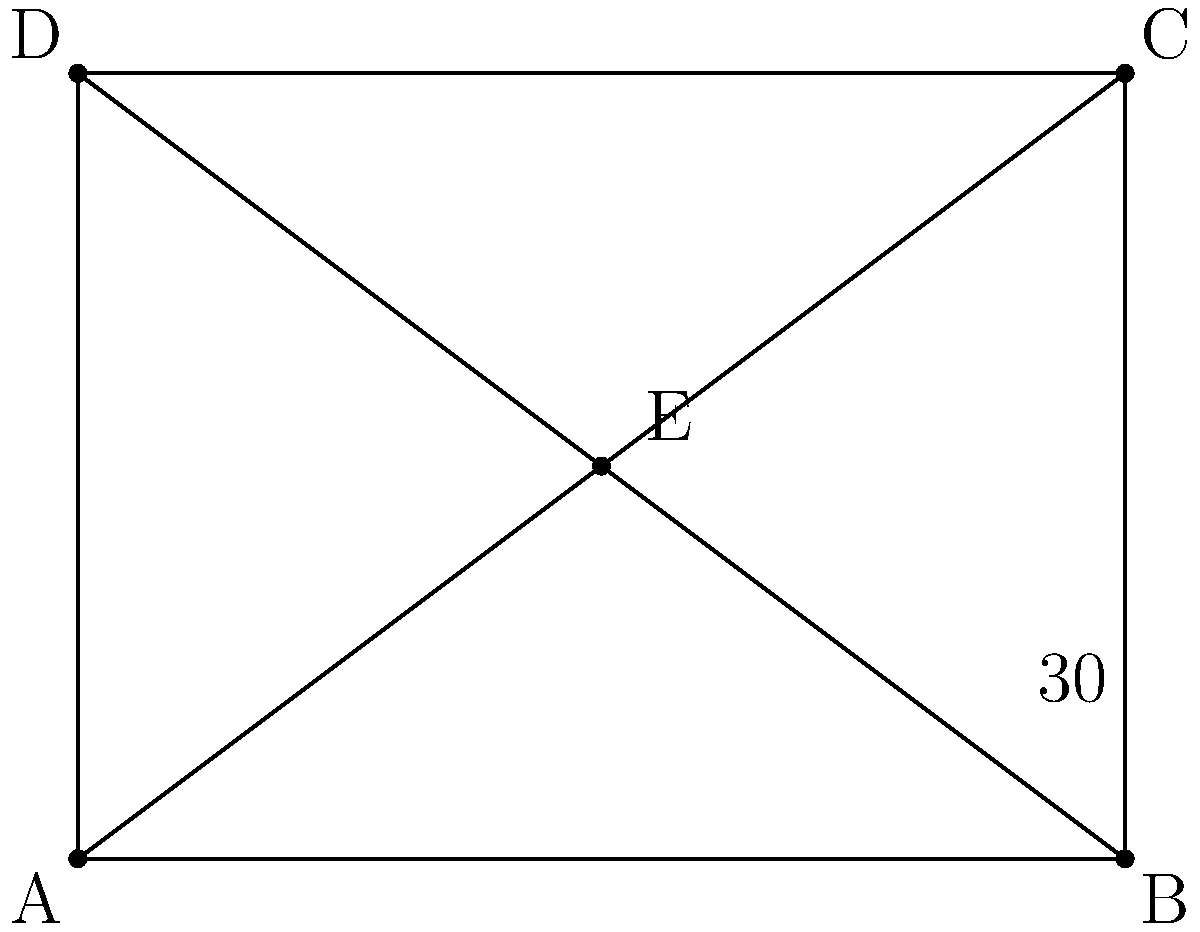In a grid-based layout design, two diagonal lines intersect at point E, forming a rectangle ABCD. If one of the angles formed by the intersecting diagonals is 30°, what is the measure of angle BEC? To solve this problem, let's follow these steps:

1) In a rectangle, the diagonals bisect each other. This means that point E is the center of the rectangle.

2) The diagonals of a rectangle are always congruent and bisect each other at right angles (90°).

3) When two lines intersect, they form four angles. The sum of these four angles is always 360°.

4) Given that one of these angles is 30°, and knowing that the angles formed by the diagonals are supplementary (they add up to 180°), we can determine that the angle opposite to the 30° angle is also 30°.

5) The remaining two angles formed by the intersecting diagonals must therefore each be:

   $$(360° - (30° + 30°)) \div 2 = 300° \div 2 = 150°$$

6) Angle BEC is one of these 150° angles.

Therefore, the measure of angle BEC is 150°.
Answer: 150° 